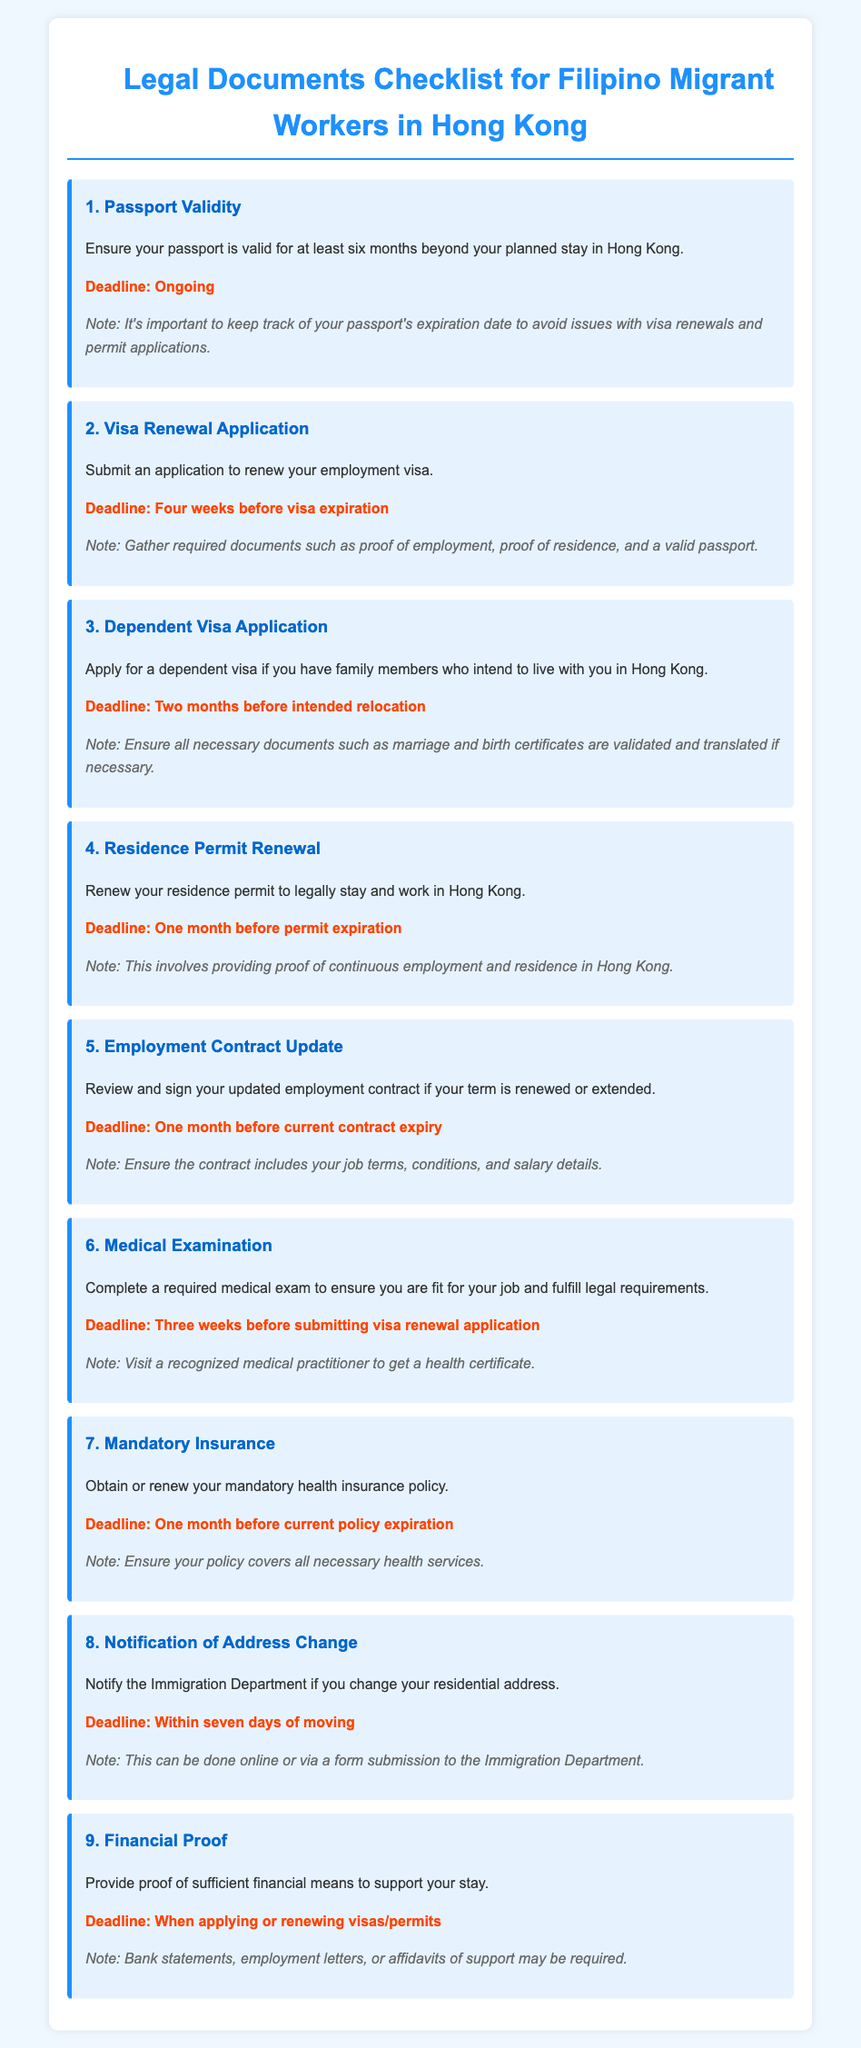what is the validity requirement for a passport? The document states that the passport must be valid for at least six months beyond the planned stay in Hong Kong.
Answer: six months when should the visa renewal application be submitted? The document specifies that the application must be submitted four weeks before visa expiration.
Answer: four weeks what document is needed for a dependent visa application? The checklist mentions that marriage and birth certificates are required for a dependent visa application.
Answer: marriage and birth certificates how many weeks before should the medical examination be completed? The deadline for the medical examination is three weeks before submitting the visa renewal application.
Answer: three weeks what must be provided to support financial means during visa applications? The document indicates that bank statements, employment letters, or affidavits of support may be required.
Answer: bank statements, employment letters, affidavits of support what is the deadline for notifying the Immigration Department of an address change? According to the document, the deadline is within seven days of moving.
Answer: seven days how often should the mandatory health insurance policy be renewed? The document states that it should be renewed one month before the current policy expiration.
Answer: one month when should you review your employment contract? The checklist specifies that you should review your employment contract one month before the current contract expiry.
Answer: one month how long before the residence permit expiration should it be renewed? The document indicates that the residence permit should be renewed one month before its expiration.
Answer: one month 